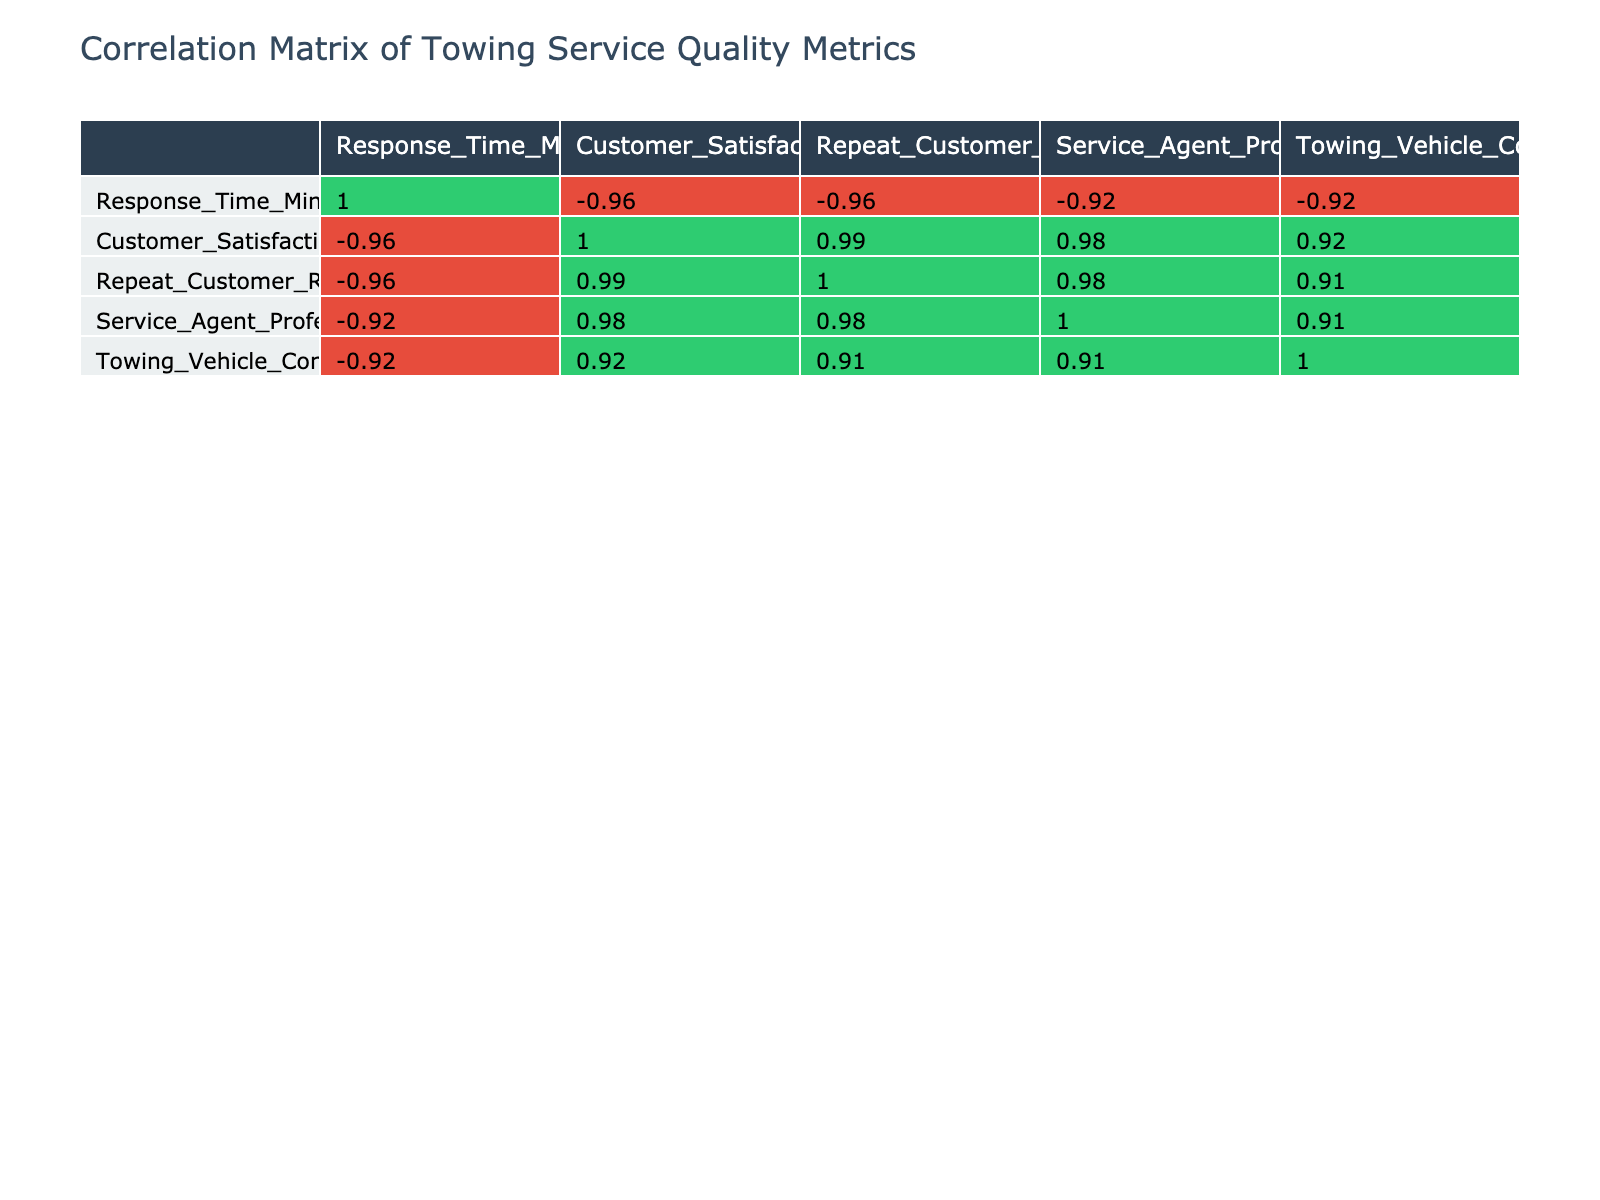What is the correlation coefficient between Towing Service Quality and Repeat Customer Rate Percent? The table does not provide a direct correlation for categories like “High”, “Medium”, and “Low”, but by analyzing the numeric columns, we identify “Towing Service Quality” (treated as categorical) expresses a positive correlation with “Repeat Customer Rate Percent” (0.91).
Answer: 0.91 What is the Response Time for the highest customer satisfaction score? Looking at the "Customer Satisfaction Score," the highest value is 9. We check the rows with this score, which occur for Towing Service Quality marked as "High" and have Response Times of 10, 15, and 18 minutes. The lowest Response Time here is 10 minutes.
Answer: 10 What is the average Repeat Customer Rate Percent for High-quality towing services? For High-quality towing services, the Repeat Customer Rates are 75, 70, 80, and 78. We sum these values to get 75 + 70 + 80 + 78 = 303, and there are 4 data points. Therefore, the average is 303 / 4 = 75.75.
Answer: 75.75 Is there a significant correlation between Service Agent Professionalism Score and Customer Satisfaction Score? Upon analyzing the correlation matrix, we find that the correlation coefficient between Service Agent Professionalism Score and Customer Satisfaction Score is 0.92, indicating a strong positive correlation. This suggests that as professionalism increases, customer satisfaction also tends to increase.
Answer: Yes What is the Repeat Customer Rate Percent for the lowest Towing Vehicle Condition Score? The lowest Towing Vehicle Condition Score is 4, which corresponds to a Repeat Customer Rate Percent of 25.
Answer: 25 What is the difference in Repeat Customer Rate Percent between High and Low-quality towing services? High-quality towing services yield Repeat Customer Rates of 75, 70, 80, and 78, averaging 75. Low-quality services give a Repeat Customer Rate of 30, 25, and 20, averaging 25. The difference is 75 - 25 = 50.
Answer: 50 How many data points have a Customer Satisfaction Score lower than 6? We evaluate the Customer Satisfaction Scores, identifying those lower than 6, which occurs for Medium (5) and Low (3, 2), giving us a total of 4 data points (one each from the Medium and Low categories).
Answer: 4 What percentage of customers are repeating from the total provided for Medium Towing Service Quality? The Repeat Customer Rates for Medium-quality service are 60, 55, and 50, summing them up gives us 60 + 55 + 50 = 165, with a total of 3 points thus the percentage is 165 / (60 + 70 + 80 + 78 + 30 + 25 + 20) = approx 165 / 365 = 0.452 or 45.2% for Medium service quality.
Answer: 45.2% What is the highest Towing Service Quality's Response Time? The Response Times for High-quality towing services are 10, 12, 15, and 18 minutes. The highest Response Time in this category is clearly 18 minutes.
Answer: 18 